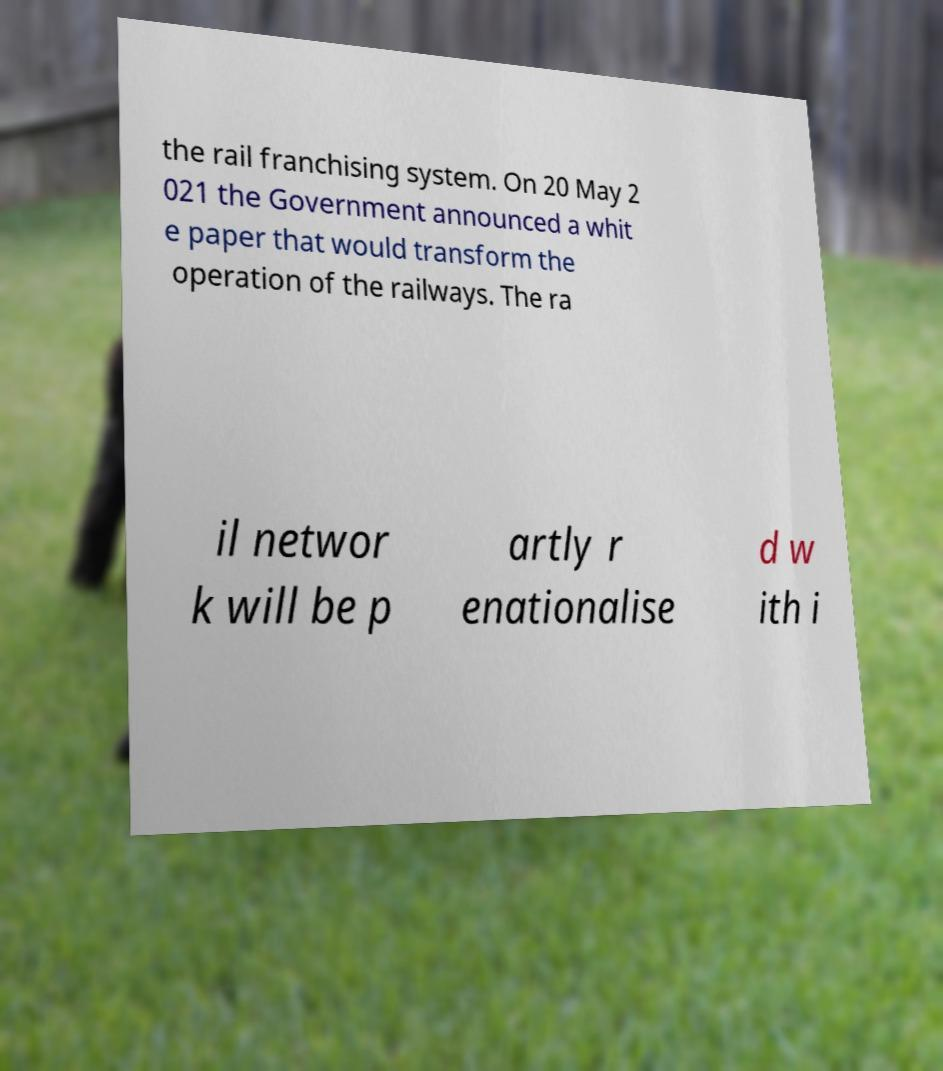I need the written content from this picture converted into text. Can you do that? the rail franchising system. On 20 May 2 021 the Government announced a whit e paper that would transform the operation of the railways. The ra il networ k will be p artly r enationalise d w ith i 